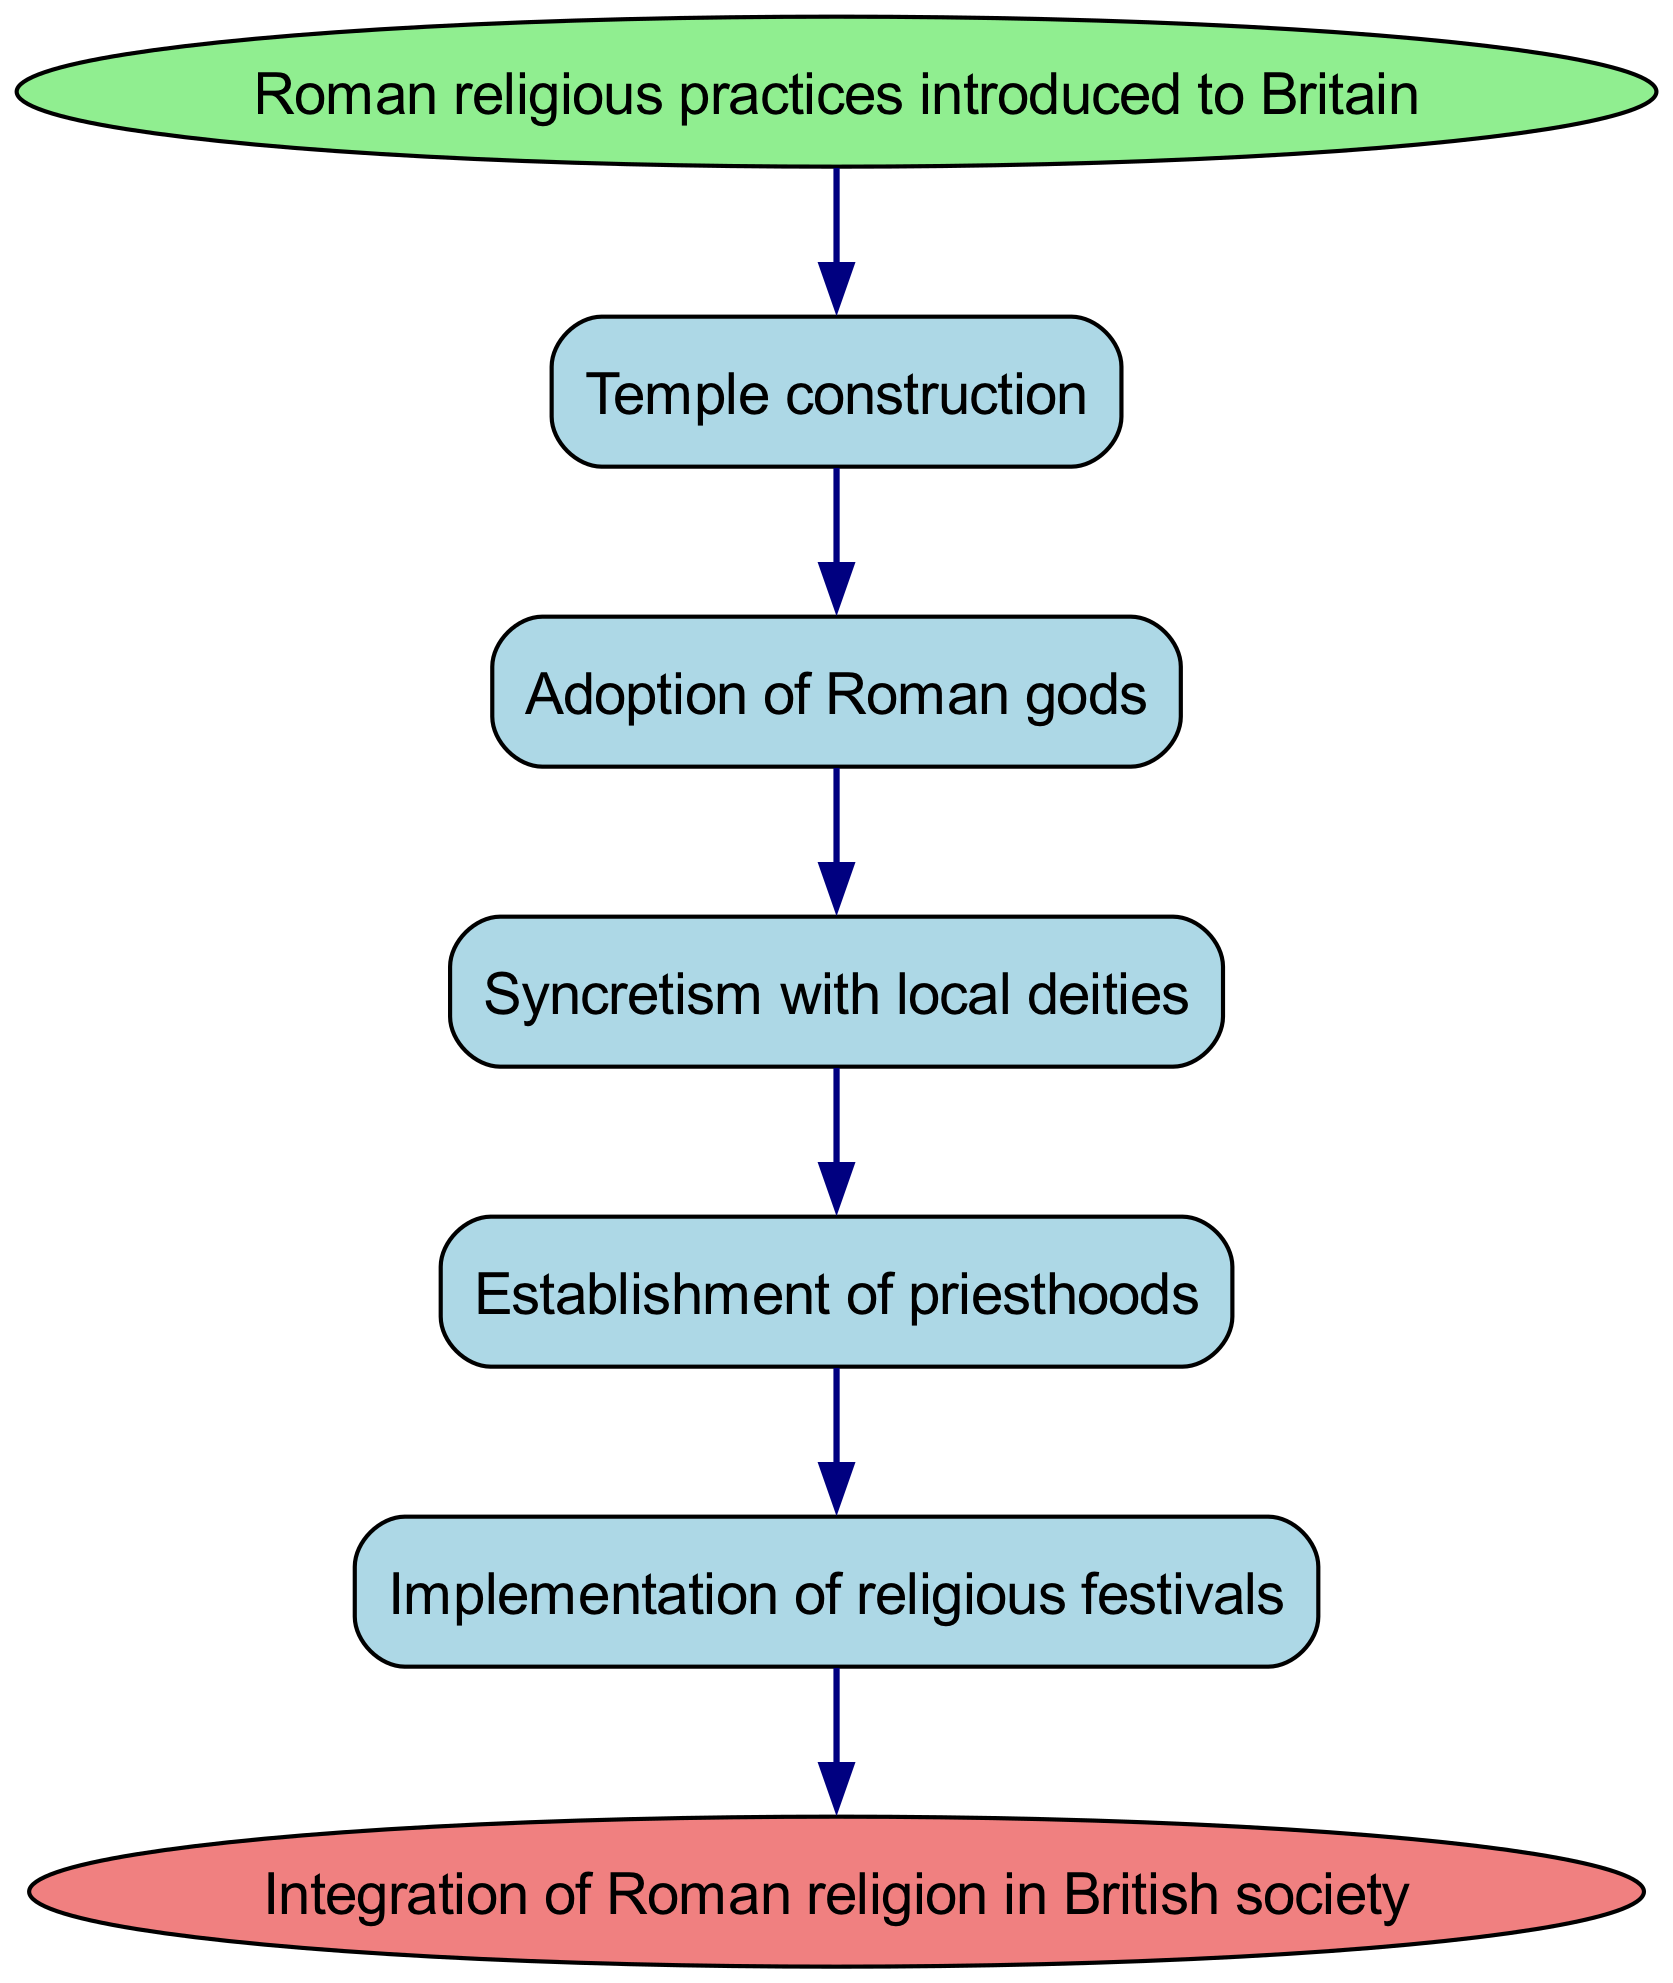What is the starting point of the diagram? The starting point of the diagram is identified as "Roman religious practices introduced to Britain," which is clearly labeled at the top of the flowchart.
Answer: Roman religious practices introduced to Britain What is the final outcome represented in the diagram? The end point of the diagram is clearly marked as "Integration of Roman religion in British society," indicating what the entire process aims to achieve.
Answer: Integration of Roman religion in British society How many processes are shown in the diagram? The diagram contains five distinct processes listed in a sequential flow, all progressing from the introduction of Roman religious practices to the final integration.
Answer: 5 What process follows "Temple construction"? According to the flow of the diagram, the next process that follows "Temple construction" is "Adoption of Roman gods," which shows the sequential relationship between these two processes.
Answer: Adoption of Roman gods What signifies the relationship between "Establishment of priesthoods" and "Implementation of religious festivals"? The diagram utilizes a directed edge to show that "Establishment of priesthoods" leads directly to "Implementation of religious festivals," indicating a clear sequential causation between these two stages.
Answer: Implementation of religious festivals Describe the process that transitions from "Adoption of Roman gods". The diagram indicates that after "Adoption of Roman gods," the next step is "Syncretism with local deities," demonstrating a blending or merging of religious practices.
Answer: Syncretism with local deities What is the cumulative function represented by the entire diagram? By analyzing the flow from start to finish, the entire diagram represents a cumulative function that illustrates the integration of Roman religious practices into British society through a series of structured processes.
Answer: Integration of Roman religion in British society Which process indicates the spread of imperial cult? The process that indicates the spread of imperial cult is called "Spread of imperial cult," following the "Implementation of religious festivals," reflecting how festivals contributed to this element of Roman religion in Britain.
Answer: Spread of imperial cult How does the diagram illustrate the concept of syncretism? The concept of syncretism is illustrated in the diagram at the node "Syncretism with local deities," which implies a fusion of Roman and local religious practices, showing how Roman religion adapted to British society.
Answer: Syncretism with local deities 